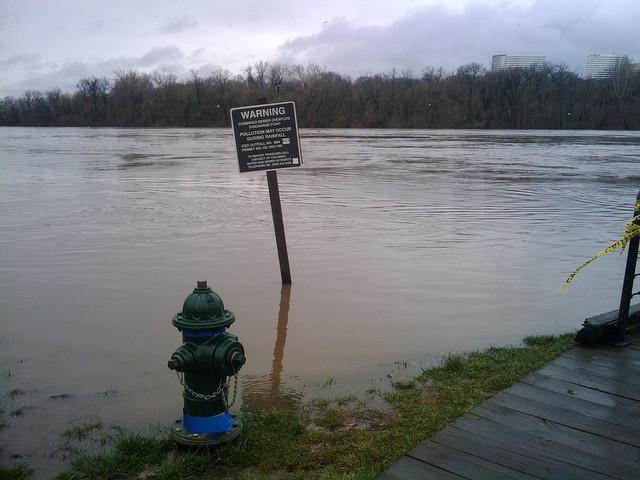What is the first word on the sign?
Concise answer only. Warning. How are the boating conditions?
Keep it brief. Good. Where is the hydrant?
Keep it brief. In water. Is the street flooded?
Short answer required. Yes. 